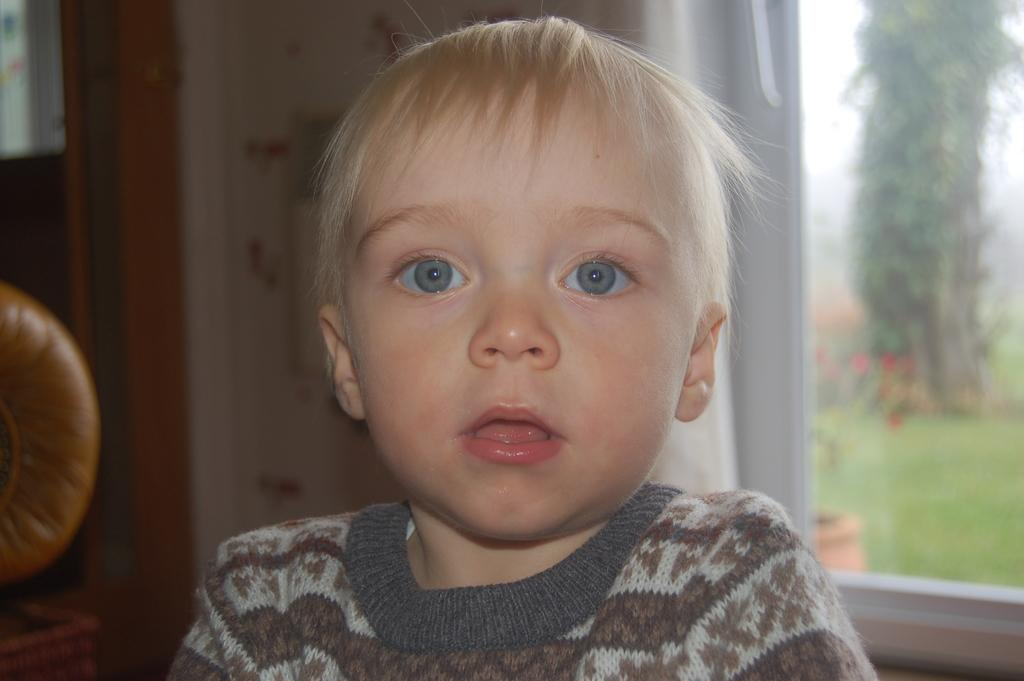Who is the main subject in the image? There is a boy in the image. What is the boy wearing? The boy is wearing a t-shirt. What can be seen in the background of the image? There is a wall, glass, trees, grass, and the sky visible in the background of the image. How are the trees, grass, and sky visible in the background? They are visible through the glass. What type of boot can be seen in the image? There is no boot present in the image. What is the boy's destination on his journey in the image? The image does not depict a journey or any indication of a destination. 